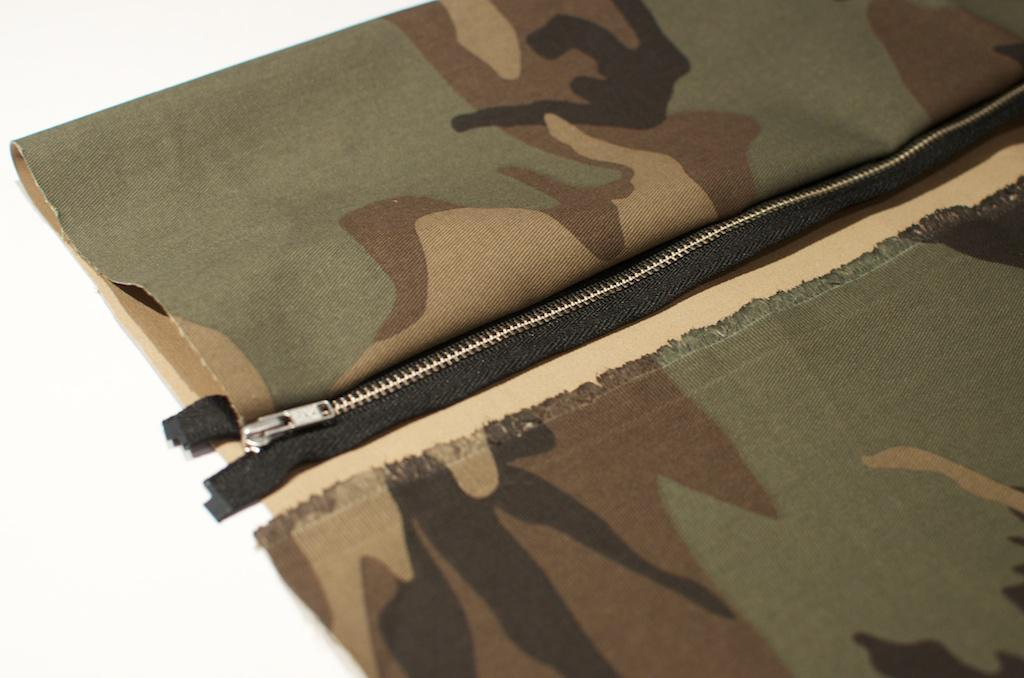What item is visible on the table in the image? There is a jacket on the table in the image. What feature does the jacket have? The jacket has a zip in the center. How many horses are visible in the image? There are no horses present in the image. What type of growth can be seen on the jacket in the image? There is no growth visible on the jacket in the image. 